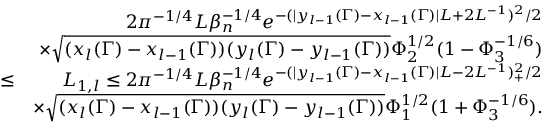<formula> <loc_0><loc_0><loc_500><loc_500>\begin{array} { r l r } & { 2 \pi ^ { - 1 \slash 4 } L \beta _ { n } ^ { - 1 \slash 4 } e ^ { - ( | y _ { l - 1 } ( \Gamma ) - x _ { l - 1 } ( \Gamma ) | L + 2 L ^ { - 1 } ) ^ { 2 } \slash 2 } } \\ & { \times \sqrt { ( x _ { l } ( \Gamma ) - x _ { l - 1 } ( \Gamma ) ) ( y _ { l } ( \Gamma ) - y _ { l - 1 } ( \Gamma ) ) } \Phi _ { 2 } ^ { 1 \slash 2 } ( 1 - \Phi _ { 3 } ^ { - 1 \slash 6 } ) } \\ & { \leq } & { L _ { 1 , l } \leq 2 \pi ^ { - 1 \slash 4 } L \beta _ { n } ^ { - 1 \slash 4 } e ^ { - ( | y _ { l - 1 } ( \Gamma ) - x _ { l - 1 } ( \Gamma ) | L - 2 L ^ { - 1 } ) _ { + } ^ { 2 } \slash 2 } } \\ & { \times \sqrt { ( x _ { l } ( \Gamma ) - x _ { l - 1 } ( \Gamma ) ) ( y _ { l } ( \Gamma ) - y _ { l - 1 } ( \Gamma ) ) } \Phi _ { 1 } ^ { 1 \slash 2 } ( 1 + \Phi _ { 3 } ^ { - 1 \slash 6 } ) . } \end{array}</formula> 